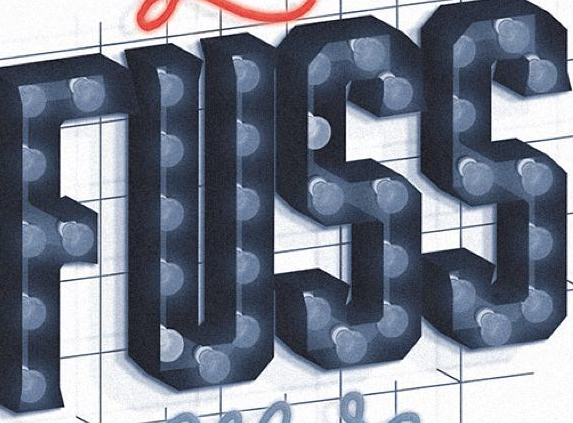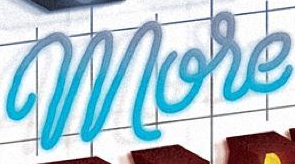Read the text from these images in sequence, separated by a semicolon. FUSS; More 